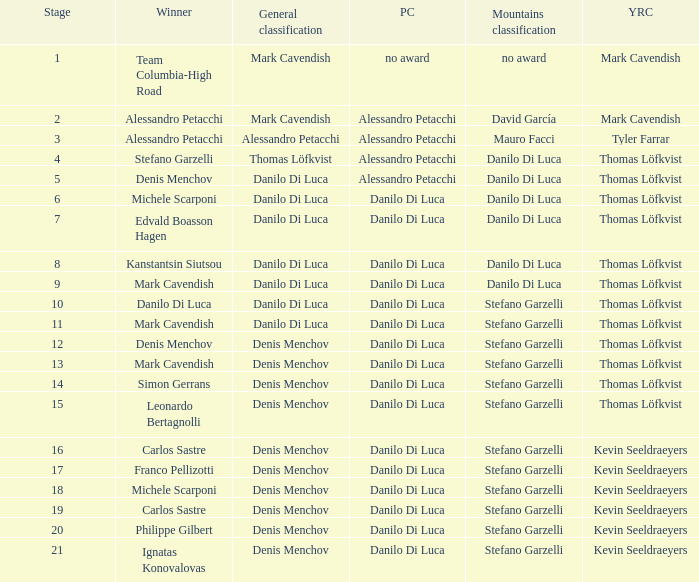When 19 is the stage who is the points classification? Danilo Di Luca. 